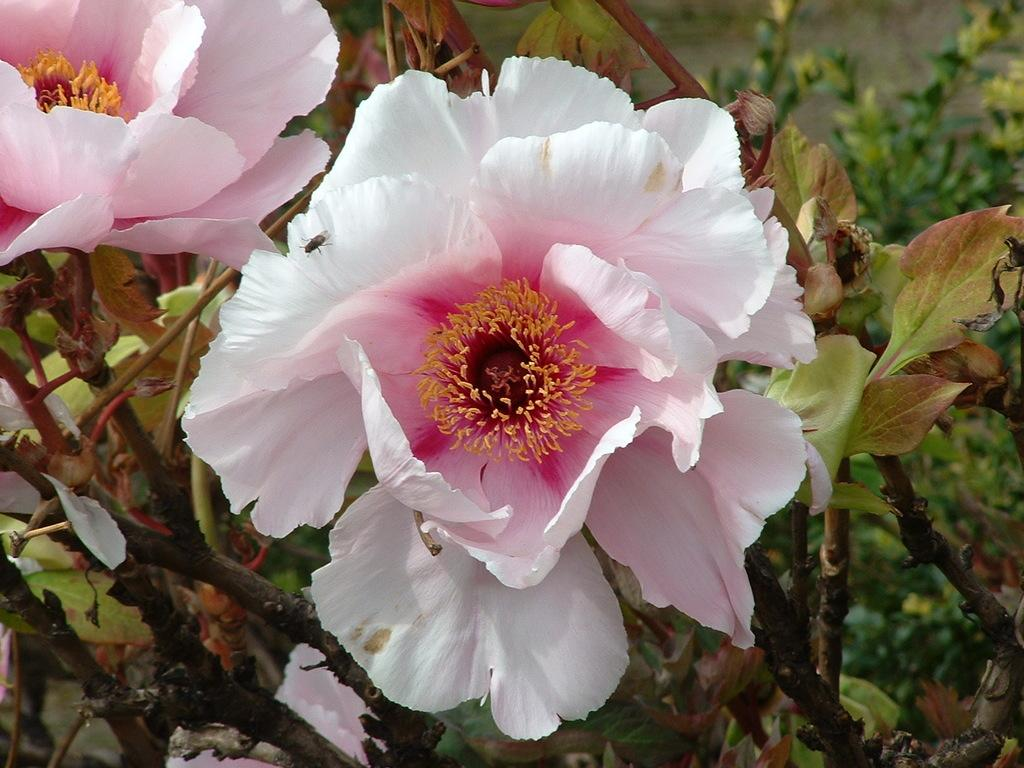What type of plant life is present in the image? There are flowers on a plant in the image. Can you describe any other living organisms in the image? There is an insect on a flower in the image. What can be seen in the background of the image? There are plants visible in the background of the image. What type of river can be seen in the image? There is no river present in the image; it features flowers, an insect, and plants. Can you describe the view from the clover in the image? There is no clover present in the image, so it is not possible to describe a view from it. 